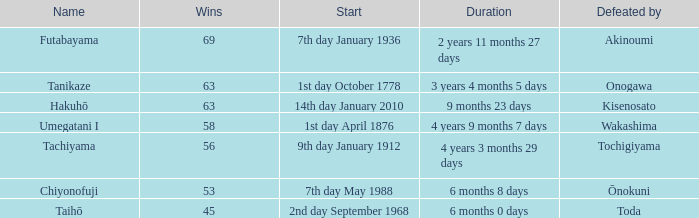Before toda's defeat, how many wins were secured? 1.0. 